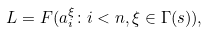<formula> <loc_0><loc_0><loc_500><loc_500>L = F ( a _ { i } ^ { \xi } \colon i < n , \xi \in \Gamma ( s ) ) ,</formula> 